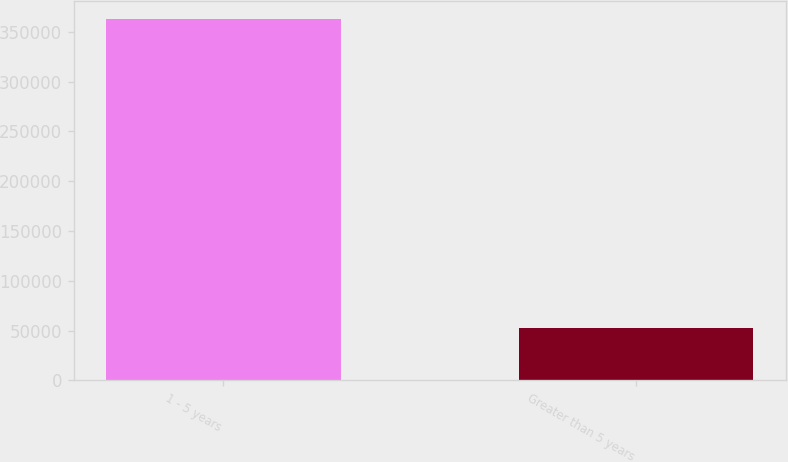<chart> <loc_0><loc_0><loc_500><loc_500><bar_chart><fcel>1 - 5 years<fcel>Greater than 5 years<nl><fcel>362373<fcel>52918<nl></chart> 